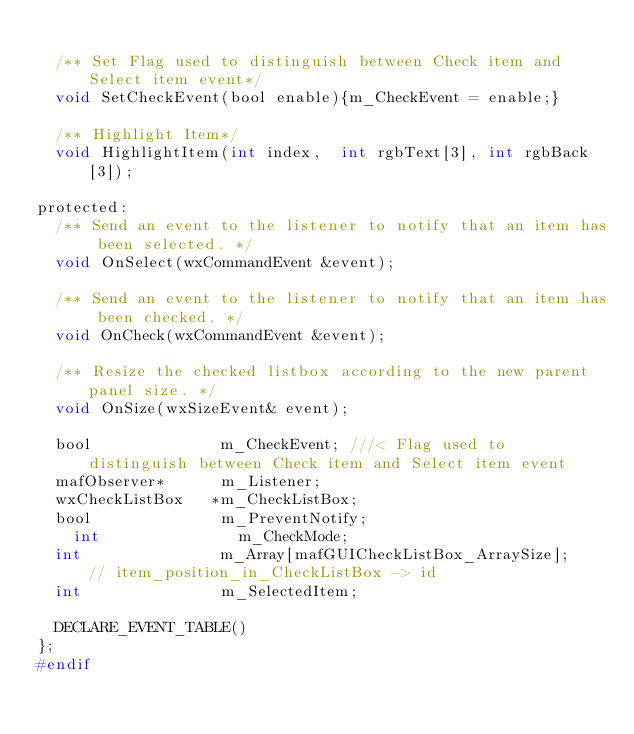<code> <loc_0><loc_0><loc_500><loc_500><_C_>
  /** Set Flag used to distinguish between Check item and Select item event*/
  void SetCheckEvent(bool enable){m_CheckEvent = enable;}

  /** Highlight Item*/
  void HighlightItem(int index,  int rgbText[3], int rgbBack[3]);

protected:
  /** Send an event to the listener to notify that an item has been selected. */
  void OnSelect(wxCommandEvent &event);

  /** Send an event to the listener to notify that an item has been checked. */
  void OnCheck(wxCommandEvent &event);

  /** Resize the checked listbox according to the new parent panel size. */
  void OnSize(wxSizeEvent& event);

  bool              m_CheckEvent; ///< Flag used to distinguish between Check item and Select item event
  mafObserver*      m_Listener;
  wxCheckListBox   *m_CheckListBox;
  bool              m_PreventNotify;
	int               m_CheckMode;
  int               m_Array[mafGUICheckListBox_ArraySize];   // item_position_in_CheckListBox -> id
  int               m_SelectedItem;

  DECLARE_EVENT_TABLE()
};
#endif
</code> 